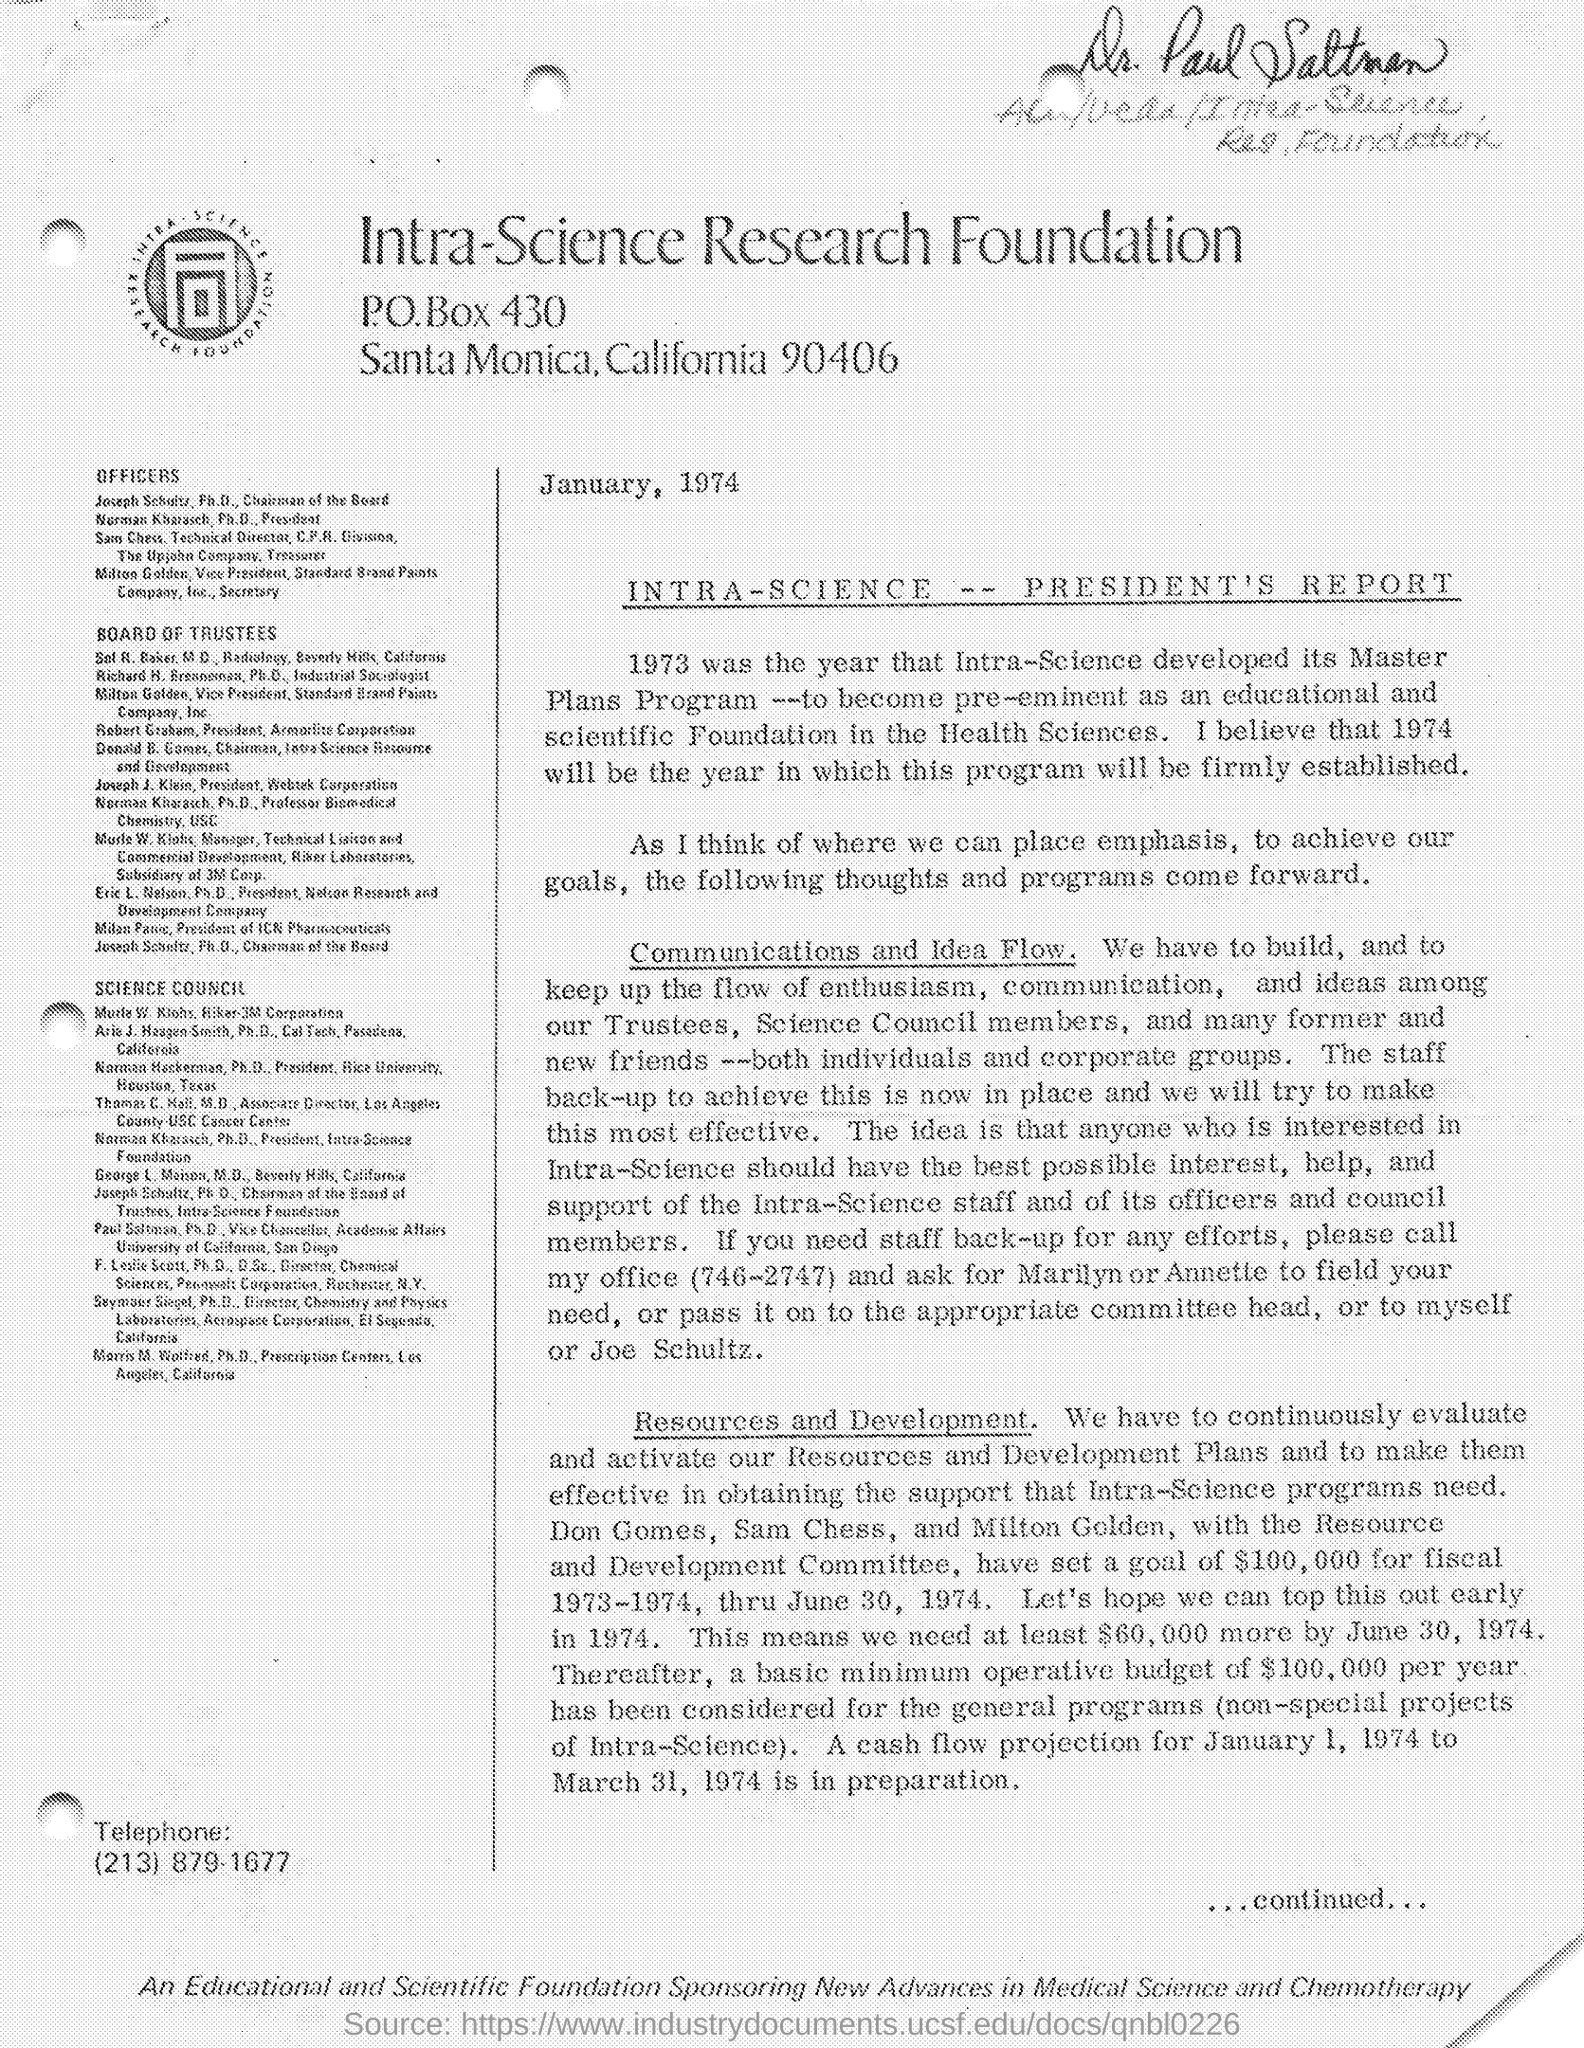Identify some key points in this picture. The goal amount is $100,000. The goal of the specified amount was made by Don Gomes, Sam Chess, and Milton Golden, members of the Resource and Development Committee. It is necessary to raise at least $60,000 by June 30, 1974. The duration of the goal was for fiscal year 1973-1974. 